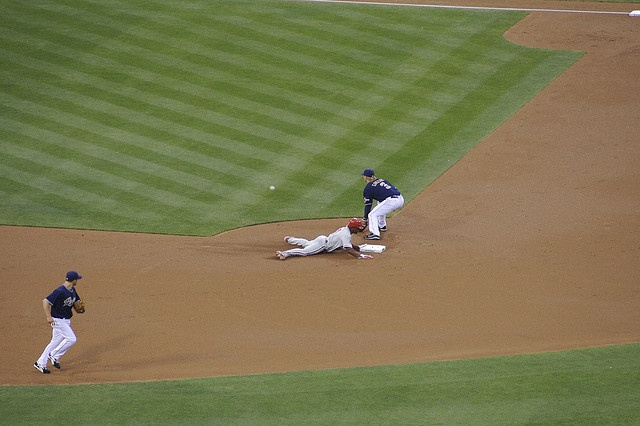Describe the objects in this image and their specific colors. I can see people in darkgreen, black, lavender, and navy tones, people in darkgreen, lavender, navy, black, and gray tones, people in darkgreen, lavender, darkgray, gray, and black tones, baseball glove in darkgreen, maroon, black, and gray tones, and baseball glove in darkgreen, purple, brown, black, and maroon tones in this image. 